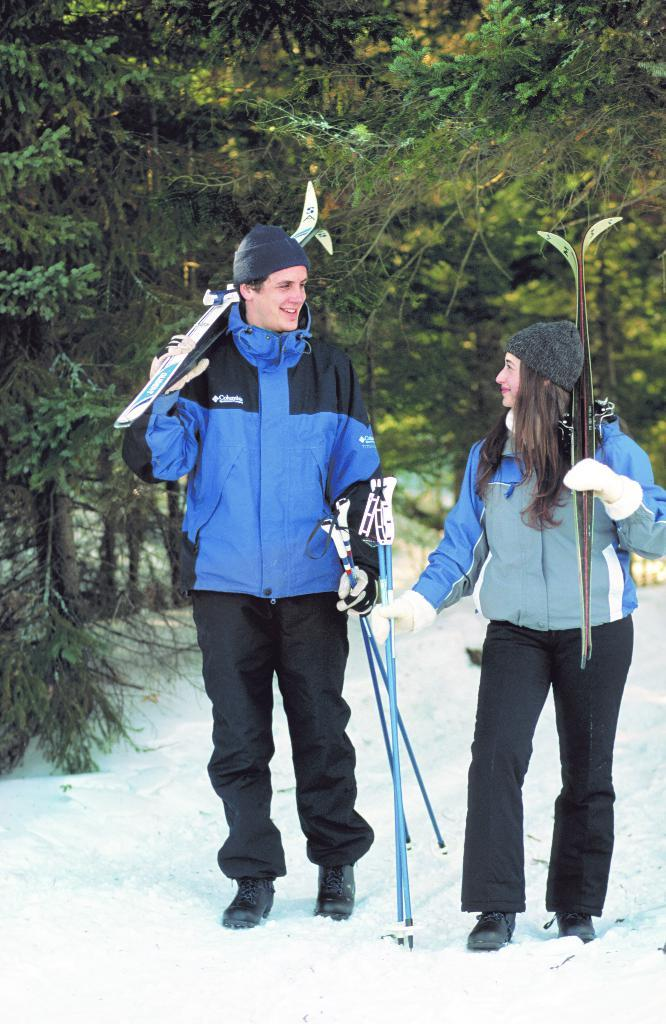How many people are in the image? There are two people in the image. What are the people doing in the image? The people are walking on the snow. What equipment are the people holding in the image? The people are holding sticks and skis. What type of clothing are the people wearing in the image? The people are wearing caps and jackets. What can be seen in the background of the image? There are trees in the background of the image. What type of quill is the person using to write in the image? There is no quill present in the image; the people are skiing and wearing ski equipment. 